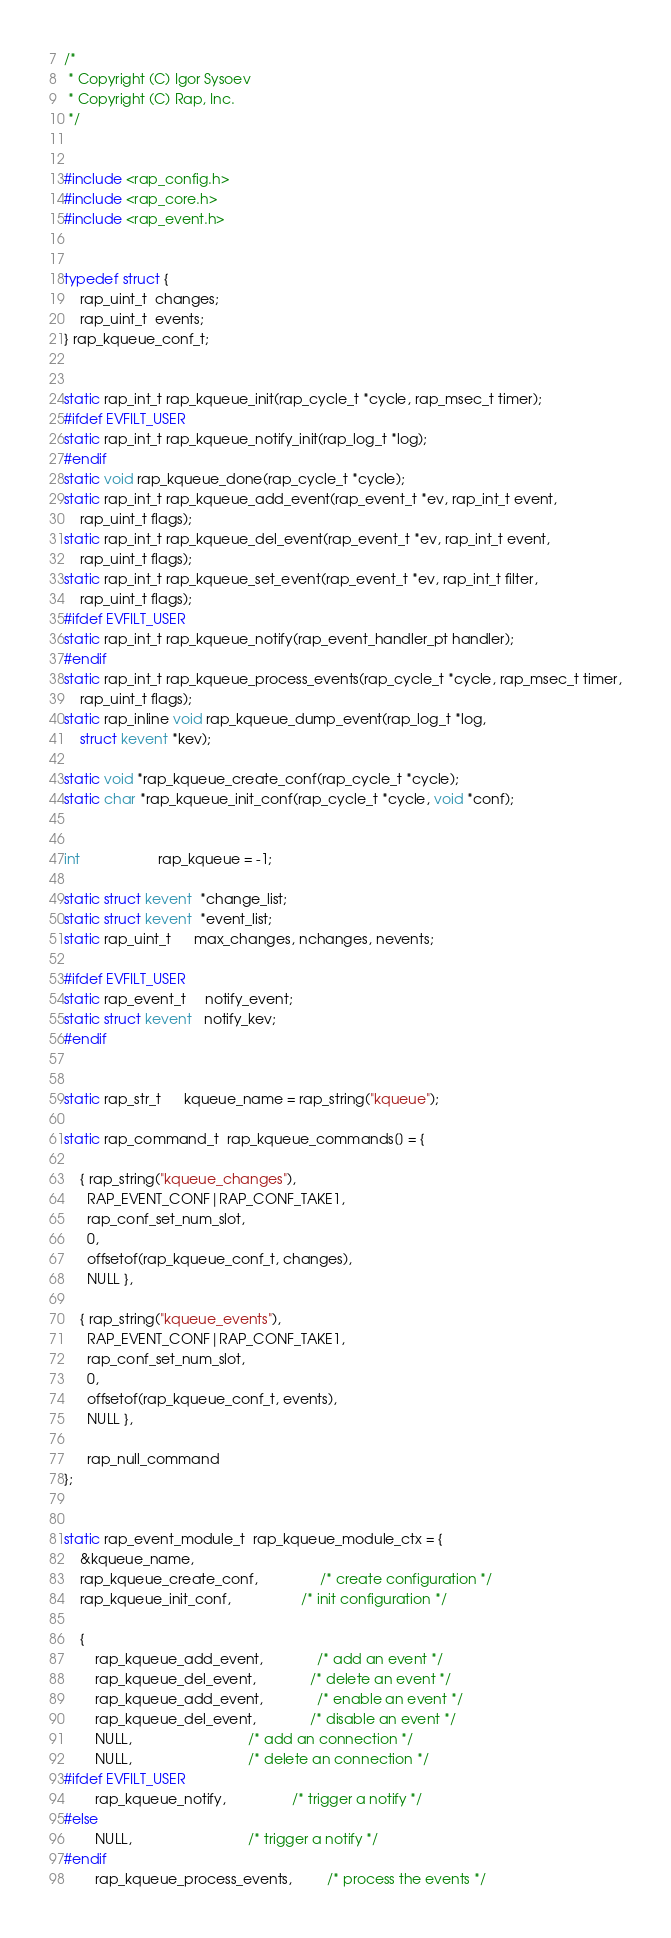<code> <loc_0><loc_0><loc_500><loc_500><_C_>
/*
 * Copyright (C) Igor Sysoev
 * Copyright (C) Rap, Inc.
 */


#include <rap_config.h>
#include <rap_core.h>
#include <rap_event.h>


typedef struct {
    rap_uint_t  changes;
    rap_uint_t  events;
} rap_kqueue_conf_t;


static rap_int_t rap_kqueue_init(rap_cycle_t *cycle, rap_msec_t timer);
#ifdef EVFILT_USER
static rap_int_t rap_kqueue_notify_init(rap_log_t *log);
#endif
static void rap_kqueue_done(rap_cycle_t *cycle);
static rap_int_t rap_kqueue_add_event(rap_event_t *ev, rap_int_t event,
    rap_uint_t flags);
static rap_int_t rap_kqueue_del_event(rap_event_t *ev, rap_int_t event,
    rap_uint_t flags);
static rap_int_t rap_kqueue_set_event(rap_event_t *ev, rap_int_t filter,
    rap_uint_t flags);
#ifdef EVFILT_USER
static rap_int_t rap_kqueue_notify(rap_event_handler_pt handler);
#endif
static rap_int_t rap_kqueue_process_events(rap_cycle_t *cycle, rap_msec_t timer,
    rap_uint_t flags);
static rap_inline void rap_kqueue_dump_event(rap_log_t *log,
    struct kevent *kev);

static void *rap_kqueue_create_conf(rap_cycle_t *cycle);
static char *rap_kqueue_init_conf(rap_cycle_t *cycle, void *conf);


int                    rap_kqueue = -1;

static struct kevent  *change_list;
static struct kevent  *event_list;
static rap_uint_t      max_changes, nchanges, nevents;

#ifdef EVFILT_USER
static rap_event_t     notify_event;
static struct kevent   notify_kev;
#endif


static rap_str_t      kqueue_name = rap_string("kqueue");

static rap_command_t  rap_kqueue_commands[] = {

    { rap_string("kqueue_changes"),
      RAP_EVENT_CONF|RAP_CONF_TAKE1,
      rap_conf_set_num_slot,
      0,
      offsetof(rap_kqueue_conf_t, changes),
      NULL },

    { rap_string("kqueue_events"),
      RAP_EVENT_CONF|RAP_CONF_TAKE1,
      rap_conf_set_num_slot,
      0,
      offsetof(rap_kqueue_conf_t, events),
      NULL },

      rap_null_command
};


static rap_event_module_t  rap_kqueue_module_ctx = {
    &kqueue_name,
    rap_kqueue_create_conf,                /* create configuration */
    rap_kqueue_init_conf,                  /* init configuration */

    {
        rap_kqueue_add_event,              /* add an event */
        rap_kqueue_del_event,              /* delete an event */
        rap_kqueue_add_event,              /* enable an event */
        rap_kqueue_del_event,              /* disable an event */
        NULL,                              /* add an connection */
        NULL,                              /* delete an connection */
#ifdef EVFILT_USER
        rap_kqueue_notify,                 /* trigger a notify */
#else
        NULL,                              /* trigger a notify */
#endif
        rap_kqueue_process_events,         /* process the events */</code> 